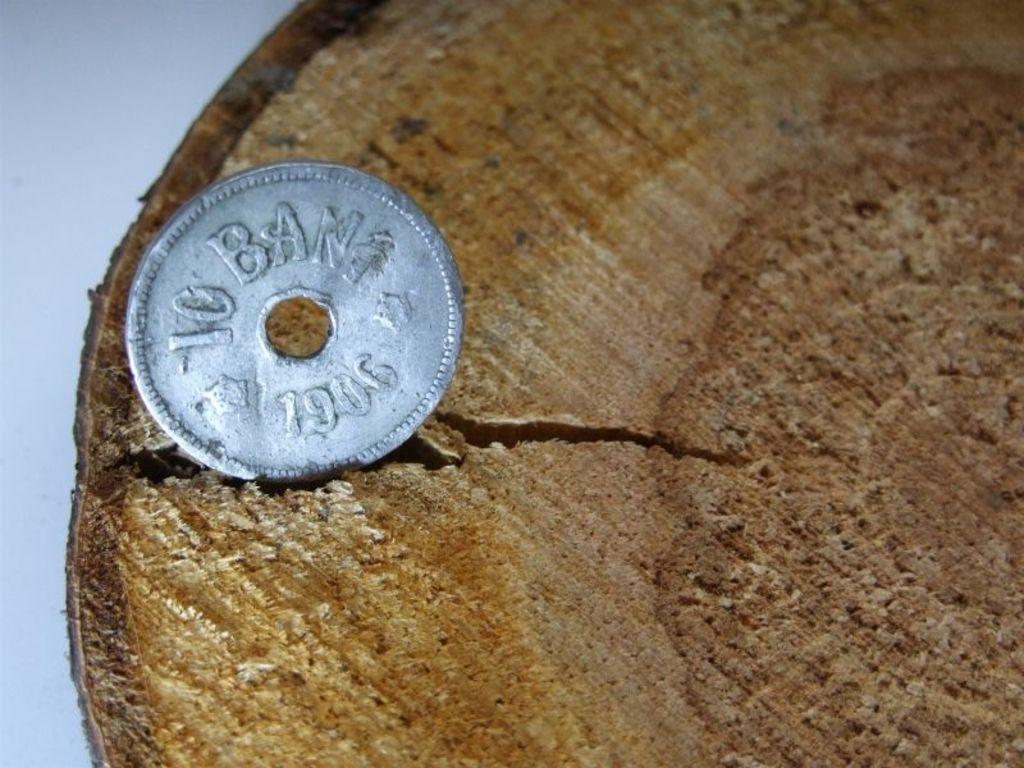<image>
Render a clear and concise summary of the photo. a silver coin in a piece of wood reading 10 Ban1 1906 